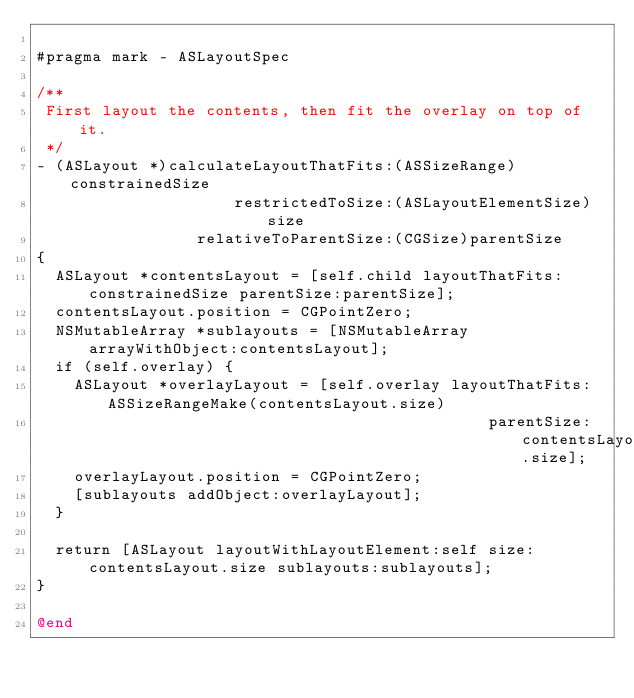<code> <loc_0><loc_0><loc_500><loc_500><_ObjectiveC_>
#pragma mark - ASLayoutSpec

/**
 First layout the contents, then fit the overlay on top of it.
 */
- (ASLayout *)calculateLayoutThatFits:(ASSizeRange)constrainedSize
                     restrictedToSize:(ASLayoutElementSize)size
                 relativeToParentSize:(CGSize)parentSize
{
  ASLayout *contentsLayout = [self.child layoutThatFits:constrainedSize parentSize:parentSize];
  contentsLayout.position = CGPointZero;
  NSMutableArray *sublayouts = [NSMutableArray arrayWithObject:contentsLayout];
  if (self.overlay) {
    ASLayout *overlayLayout = [self.overlay layoutThatFits:ASSizeRangeMake(contentsLayout.size)
                                                parentSize:contentsLayout.size];
    overlayLayout.position = CGPointZero;
    [sublayouts addObject:overlayLayout];
  }
  
  return [ASLayout layoutWithLayoutElement:self size:contentsLayout.size sublayouts:sublayouts];
}

@end
</code> 